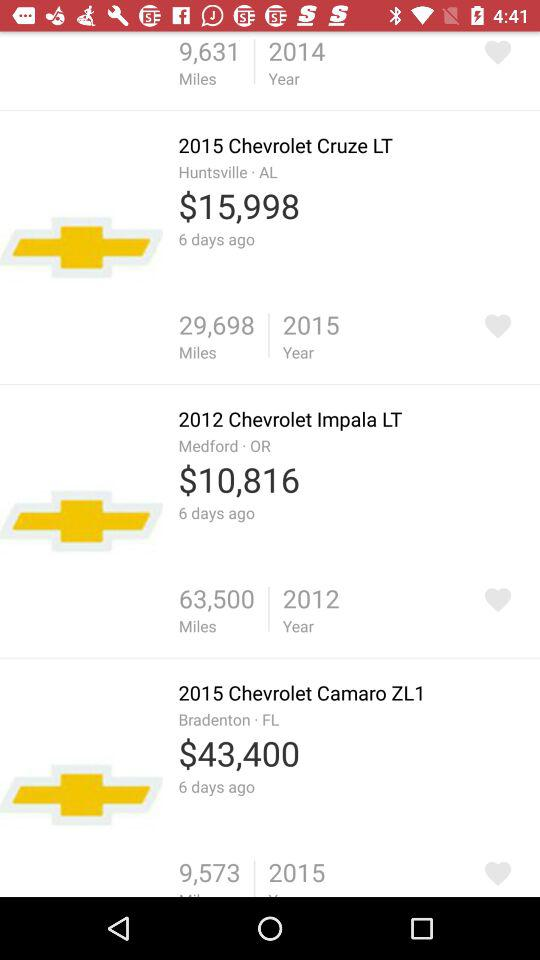How many miles has the "2015 Chevrolet Cruze LT" covered? The "2015 Chevrolet Cruze LT" has covered 29,698 miles. 